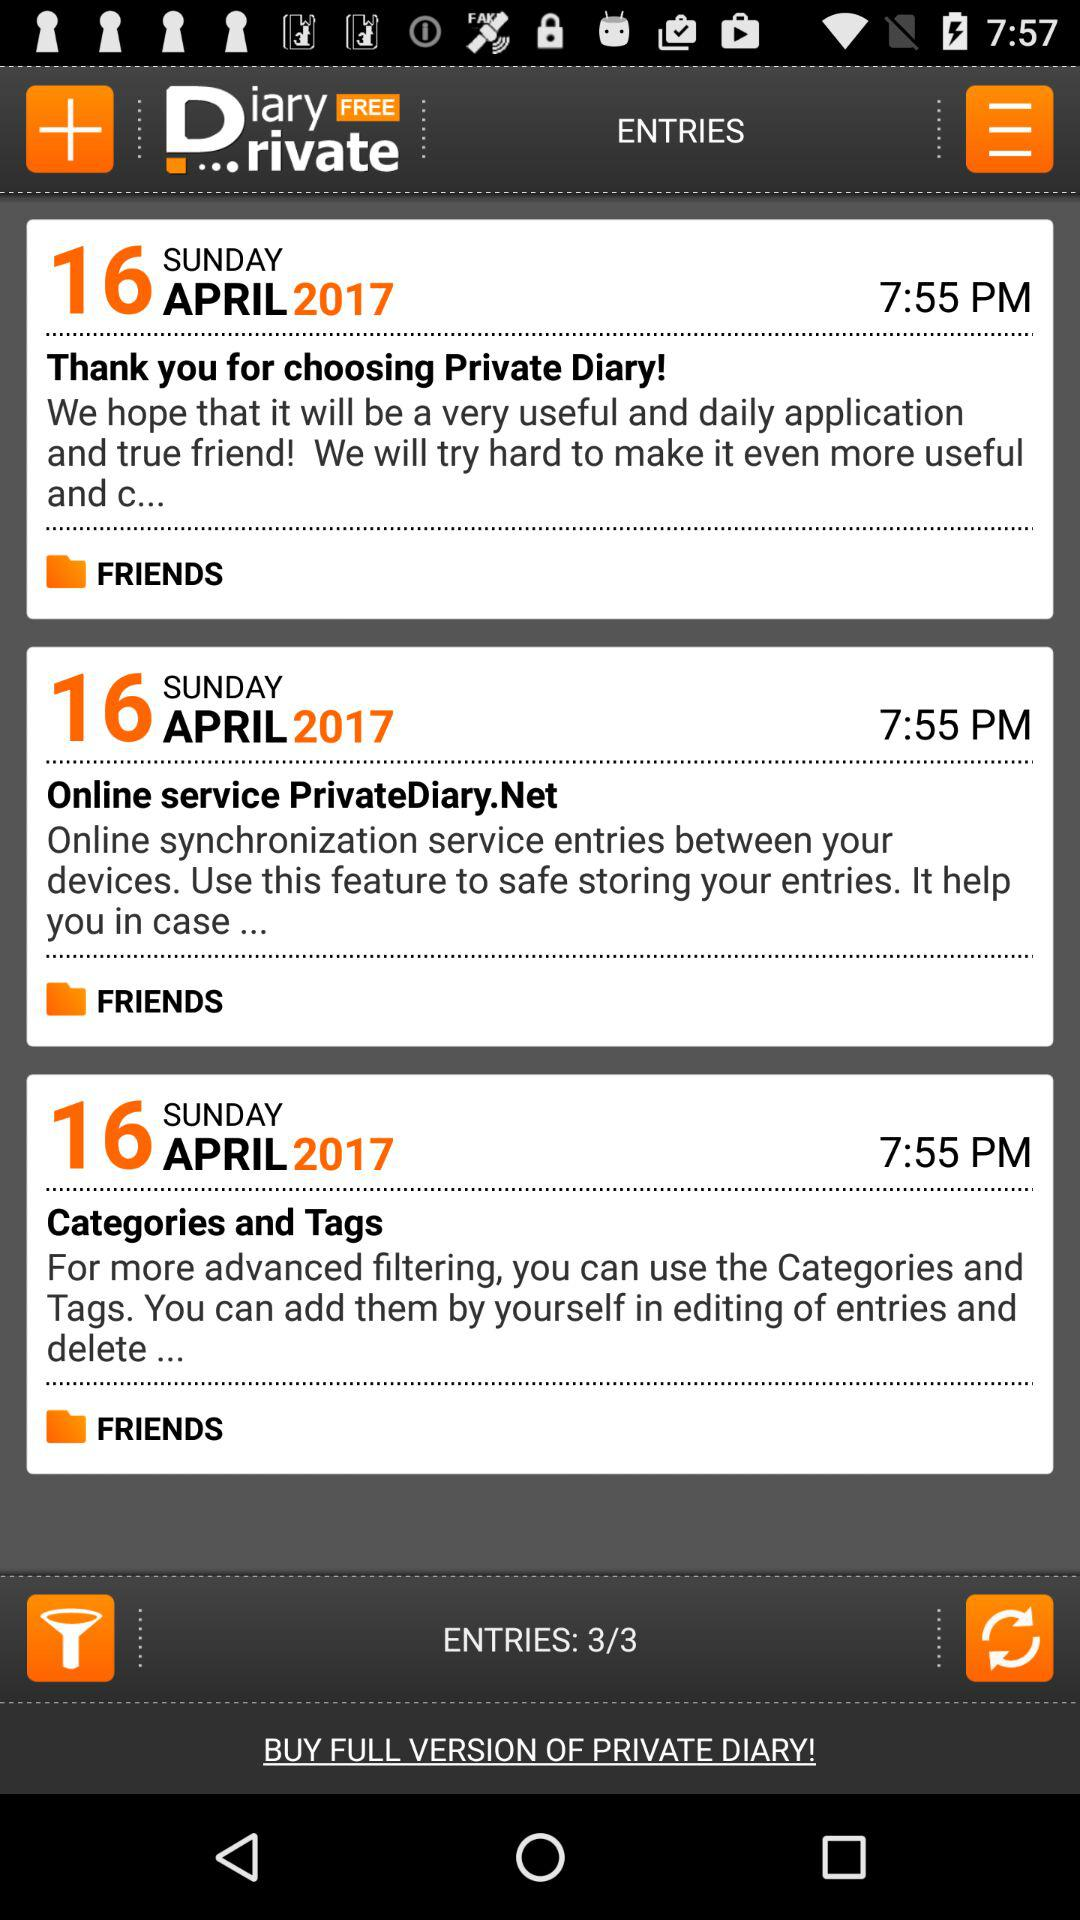How many entries are there in total?
Answer the question using a single word or phrase. 3 